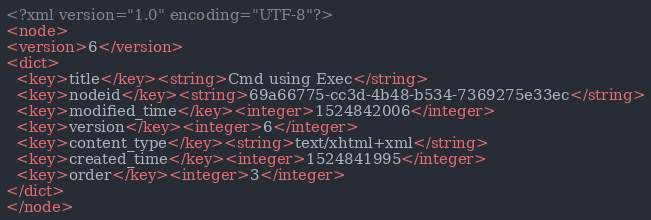Convert code to text. <code><loc_0><loc_0><loc_500><loc_500><_XML_><?xml version="1.0" encoding="UTF-8"?>
<node>
<version>6</version>
<dict>
  <key>title</key><string>Cmd using Exec</string>
  <key>nodeid</key><string>69a66775-cc3d-4b48-b534-7369275e33ec</string>
  <key>modified_time</key><integer>1524842006</integer>
  <key>version</key><integer>6</integer>
  <key>content_type</key><string>text/xhtml+xml</string>
  <key>created_time</key><integer>1524841995</integer>
  <key>order</key><integer>3</integer>
</dict>
</node>
</code> 